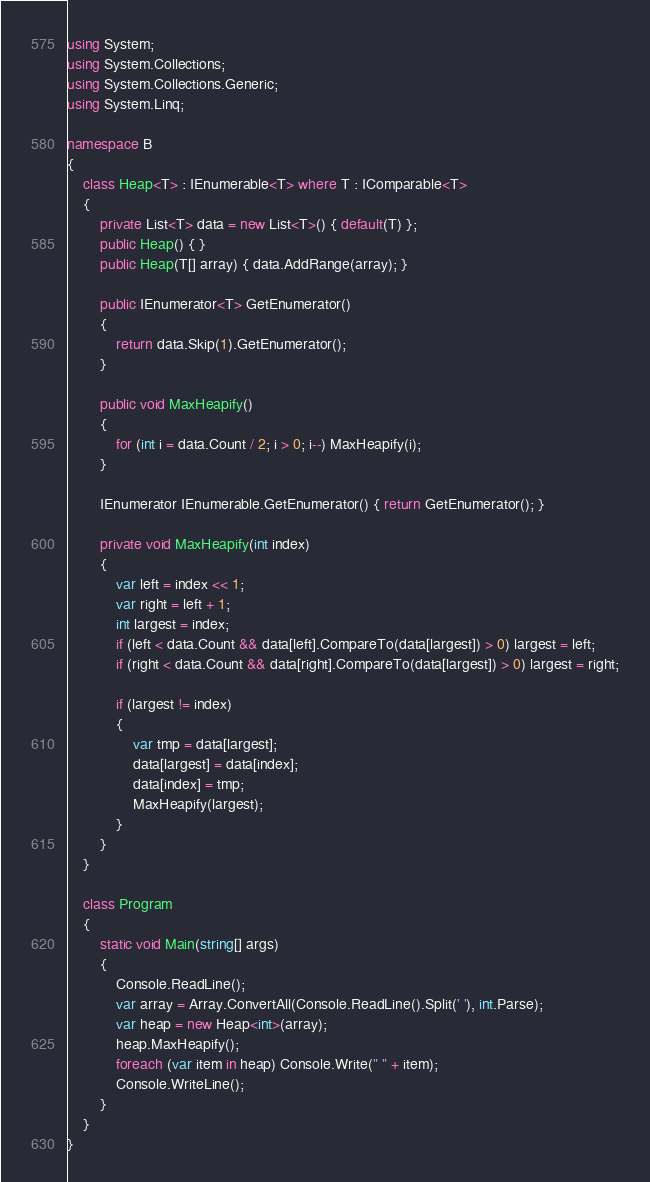Convert code to text. <code><loc_0><loc_0><loc_500><loc_500><_C#_>using System;
using System.Collections;
using System.Collections.Generic;
using System.Linq;

namespace B
{
    class Heap<T> : IEnumerable<T> where T : IComparable<T>
    {
        private List<T> data = new List<T>() { default(T) };
        public Heap() { }
        public Heap(T[] array) { data.AddRange(array); }

        public IEnumerator<T> GetEnumerator()
        {
            return data.Skip(1).GetEnumerator();
        }

        public void MaxHeapify()
        {
            for (int i = data.Count / 2; i > 0; i--) MaxHeapify(i);
        }

        IEnumerator IEnumerable.GetEnumerator() { return GetEnumerator(); }

        private void MaxHeapify(int index)
        {
            var left = index << 1;
            var right = left + 1;
            int largest = index;
            if (left < data.Count && data[left].CompareTo(data[largest]) > 0) largest = left;
            if (right < data.Count && data[right].CompareTo(data[largest]) > 0) largest = right;

            if (largest != index)
            {
                var tmp = data[largest];
                data[largest] = data[index];
                data[index] = tmp;
                MaxHeapify(largest);
            }
        }
    }

    class Program
    {
        static void Main(string[] args)
        {
            Console.ReadLine();
            var array = Array.ConvertAll(Console.ReadLine().Split(' '), int.Parse);
            var heap = new Heap<int>(array);
            heap.MaxHeapify();
            foreach (var item in heap) Console.Write(" " + item);
            Console.WriteLine();
        }
    }
}</code> 